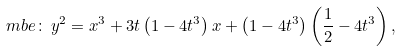<formula> <loc_0><loc_0><loc_500><loc_500>\ m b e \colon \, y ^ { 2 } = x ^ { 3 } + 3 t \left ( 1 - 4 t ^ { 3 } \right ) x + \left ( 1 - 4 t ^ { 3 } \right ) \left ( \frac { 1 } { 2 } - 4 t ^ { 3 } \right ) ,</formula> 